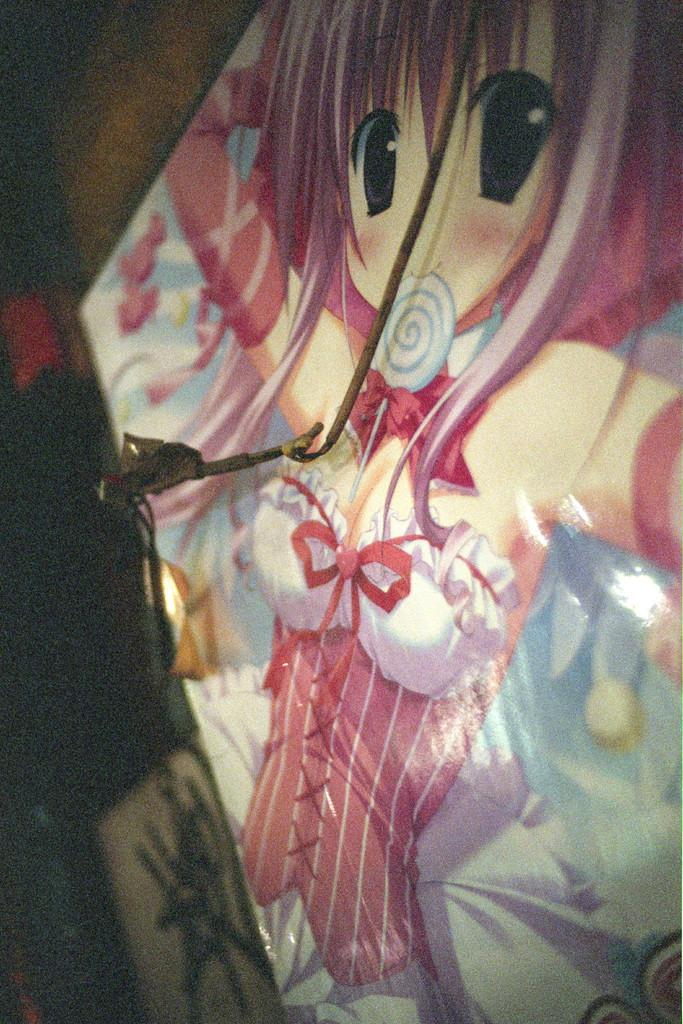What is the main object in the image? There is a huge board in the image. Who or what is on the board? A woman wearing a red and white colored dress is on the board. What can be observed about the background of the image? The background of the image is dark. What type of maid is depicted in the image? There is no maid present in the image; it features a woman on a huge board. How does the woman's memory affect the image? The image does not depict any memory or mental state of the woman, so it cannot be determined how her memory affects the image. 